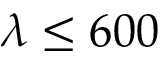Convert formula to latex. <formula><loc_0><loc_0><loc_500><loc_500>\lambda \leq 6 0 0</formula> 